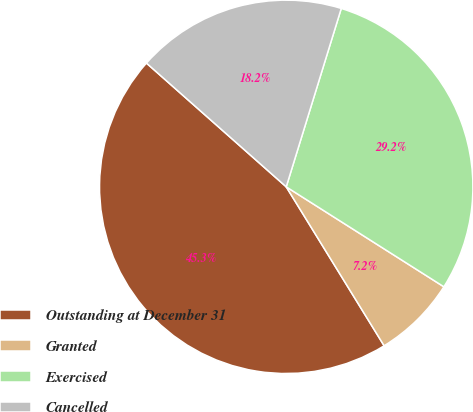Convert chart. <chart><loc_0><loc_0><loc_500><loc_500><pie_chart><fcel>Outstanding at December 31<fcel>Granted<fcel>Exercised<fcel>Cancelled<nl><fcel>45.32%<fcel>7.22%<fcel>29.23%<fcel>18.23%<nl></chart> 